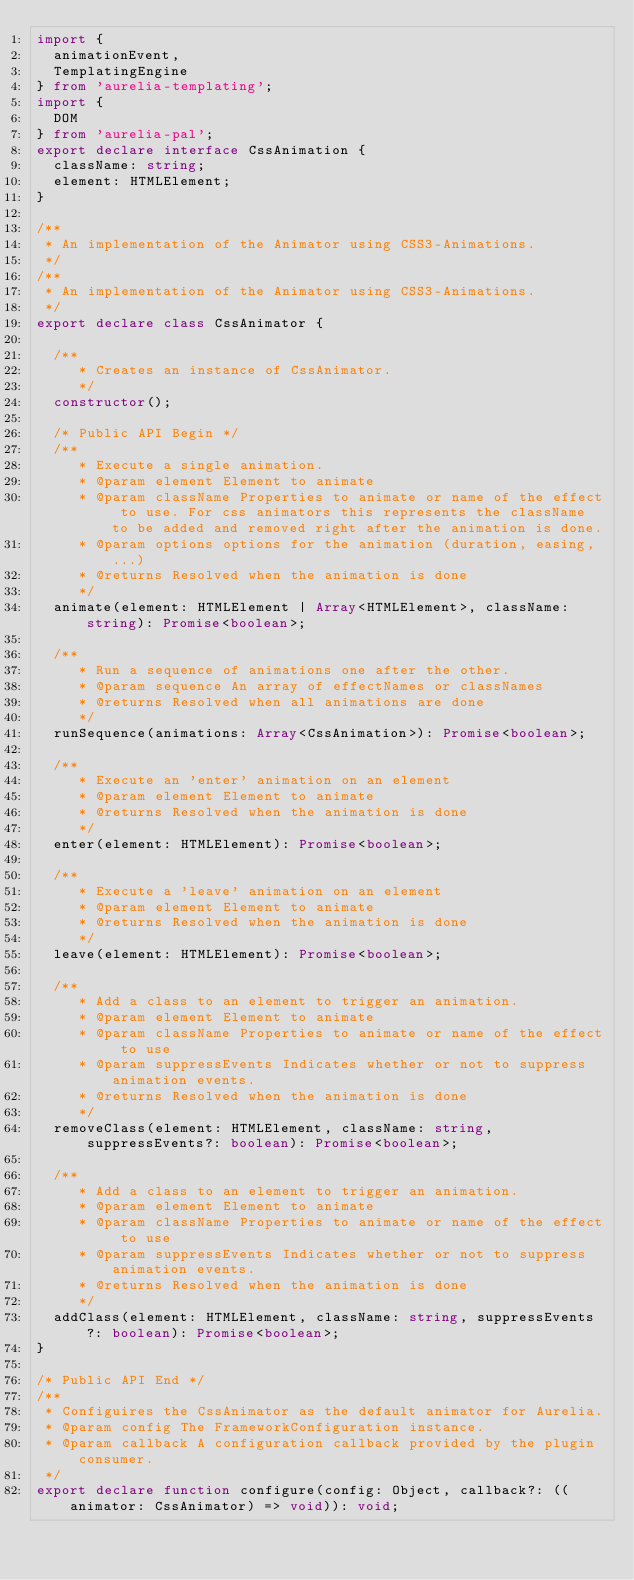Convert code to text. <code><loc_0><loc_0><loc_500><loc_500><_TypeScript_>import {
  animationEvent,
  TemplatingEngine
} from 'aurelia-templating';
import {
  DOM
} from 'aurelia-pal';
export declare interface CssAnimation {
  className: string;
  element: HTMLElement;
}

/**
 * An implementation of the Animator using CSS3-Animations.
 */
/**
 * An implementation of the Animator using CSS3-Animations.
 */
export declare class CssAnimator {
  
  /**
     * Creates an instance of CssAnimator.
     */
  constructor();
  
  /* Public API Begin */
  /**
     * Execute a single animation.
     * @param element Element to animate
     * @param className Properties to animate or name of the effect to use. For css animators this represents the className to be added and removed right after the animation is done.
     * @param options options for the animation (duration, easing, ...)
     * @returns Resolved when the animation is done
     */
  animate(element: HTMLElement | Array<HTMLElement>, className: string): Promise<boolean>;
  
  /**
     * Run a sequence of animations one after the other.
     * @param sequence An array of effectNames or classNames
     * @returns Resolved when all animations are done
     */
  runSequence(animations: Array<CssAnimation>): Promise<boolean>;
  
  /**
     * Execute an 'enter' animation on an element
     * @param element Element to animate
     * @returns Resolved when the animation is done
     */
  enter(element: HTMLElement): Promise<boolean>;
  
  /**
     * Execute a 'leave' animation on an element
     * @param element Element to animate
     * @returns Resolved when the animation is done
     */
  leave(element: HTMLElement): Promise<boolean>;
  
  /**
     * Add a class to an element to trigger an animation.
     * @param element Element to animate
     * @param className Properties to animate or name of the effect to use
     * @param suppressEvents Indicates whether or not to suppress animation events.
     * @returns Resolved when the animation is done
     */
  removeClass(element: HTMLElement, className: string, suppressEvents?: boolean): Promise<boolean>;
  
  /**
     * Add a class to an element to trigger an animation.
     * @param element Element to animate
     * @param className Properties to animate or name of the effect to use
     * @param suppressEvents Indicates whether or not to suppress animation events.
     * @returns Resolved when the animation is done
     */
  addClass(element: HTMLElement, className: string, suppressEvents?: boolean): Promise<boolean>;
}

/* Public API End */
/**
 * Configuires the CssAnimator as the default animator for Aurelia.
 * @param config The FrameworkConfiguration instance.
 * @param callback A configuration callback provided by the plugin consumer.
 */
export declare function configure(config: Object, callback?: ((animator: CssAnimator) => void)): void;</code> 